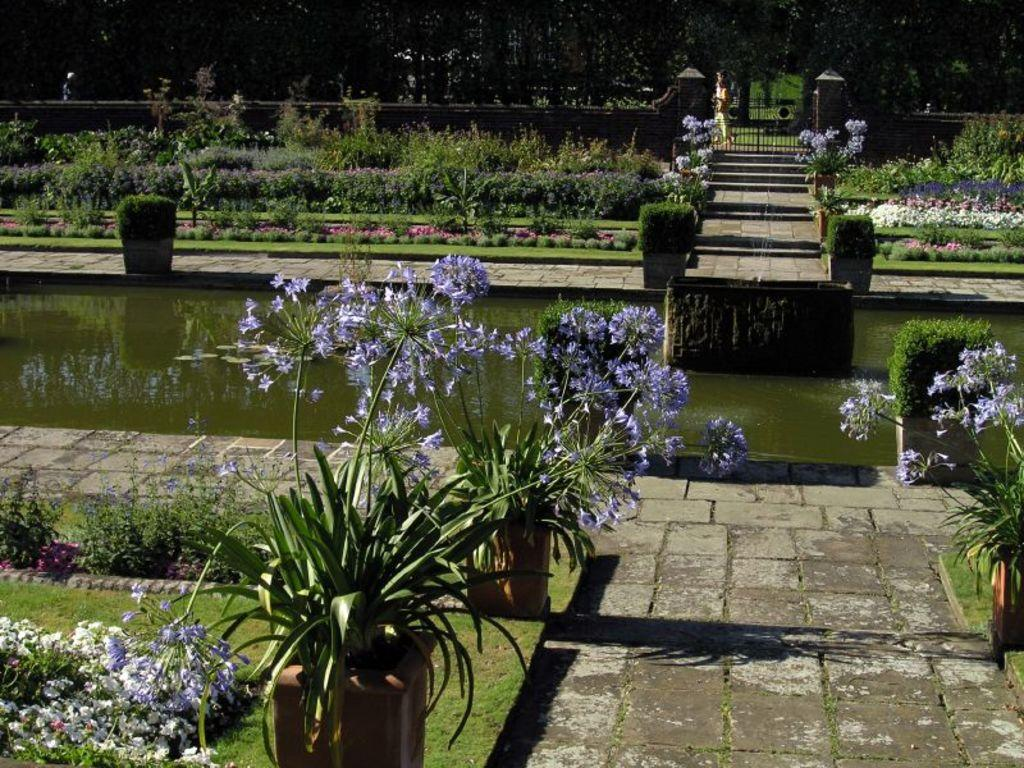What type of vegetation can be seen in the image? There are plants, flowers, and grass visible in the image. What type of structure is present in the image? There is a gate in the image. What can be seen in the background of the image? There are trees in the background of the image. What natural element is visible in the image? Water is visible in the image. What is the opinion of the horse about the plants in the image? There is no horse present in the image, so it is not possible to determine its opinion about the plants. 